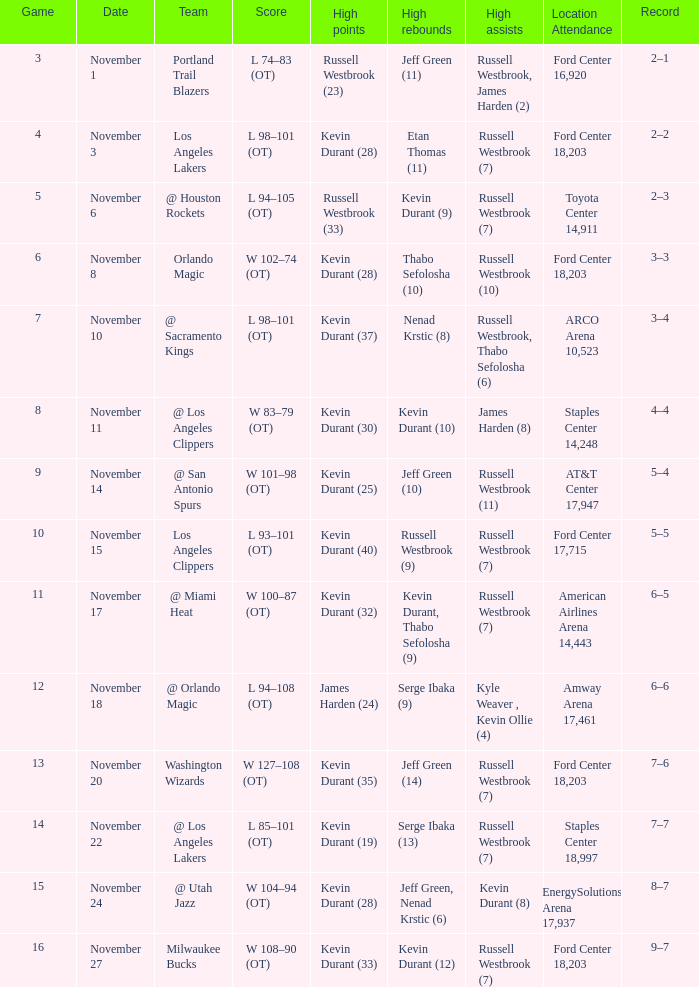Where was the game in which Kevin Durant (25) did the most high points played? AT&T Center 17,947. 